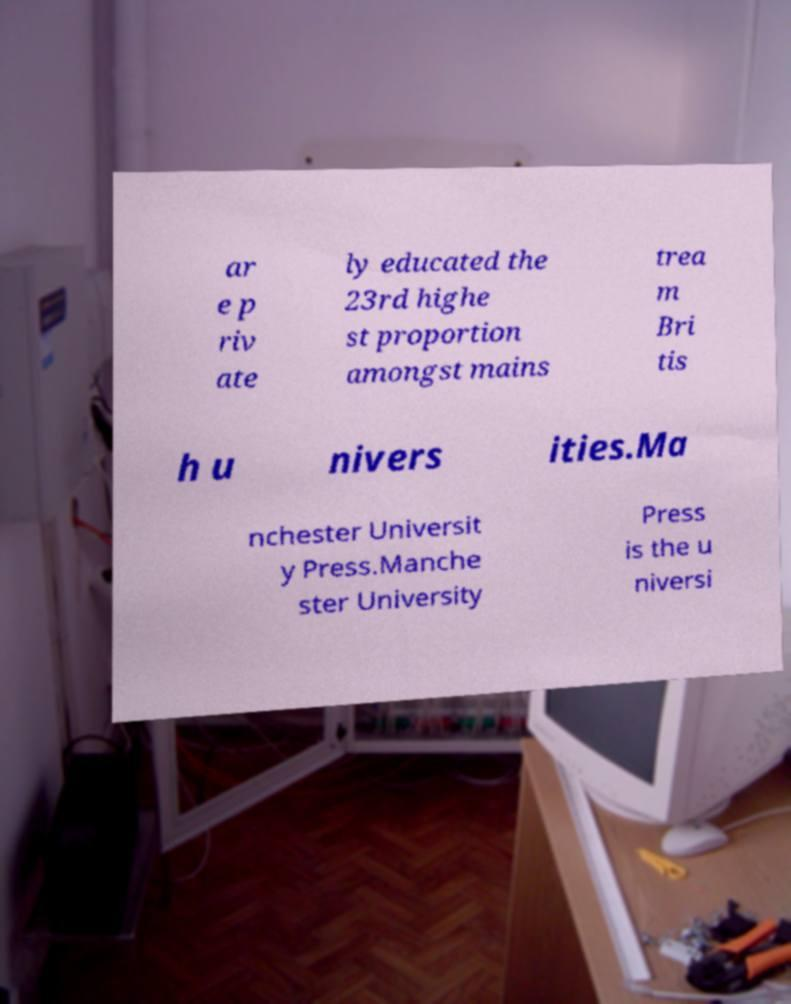For documentation purposes, I need the text within this image transcribed. Could you provide that? ar e p riv ate ly educated the 23rd highe st proportion amongst mains trea m Bri tis h u nivers ities.Ma nchester Universit y Press.Manche ster University Press is the u niversi 